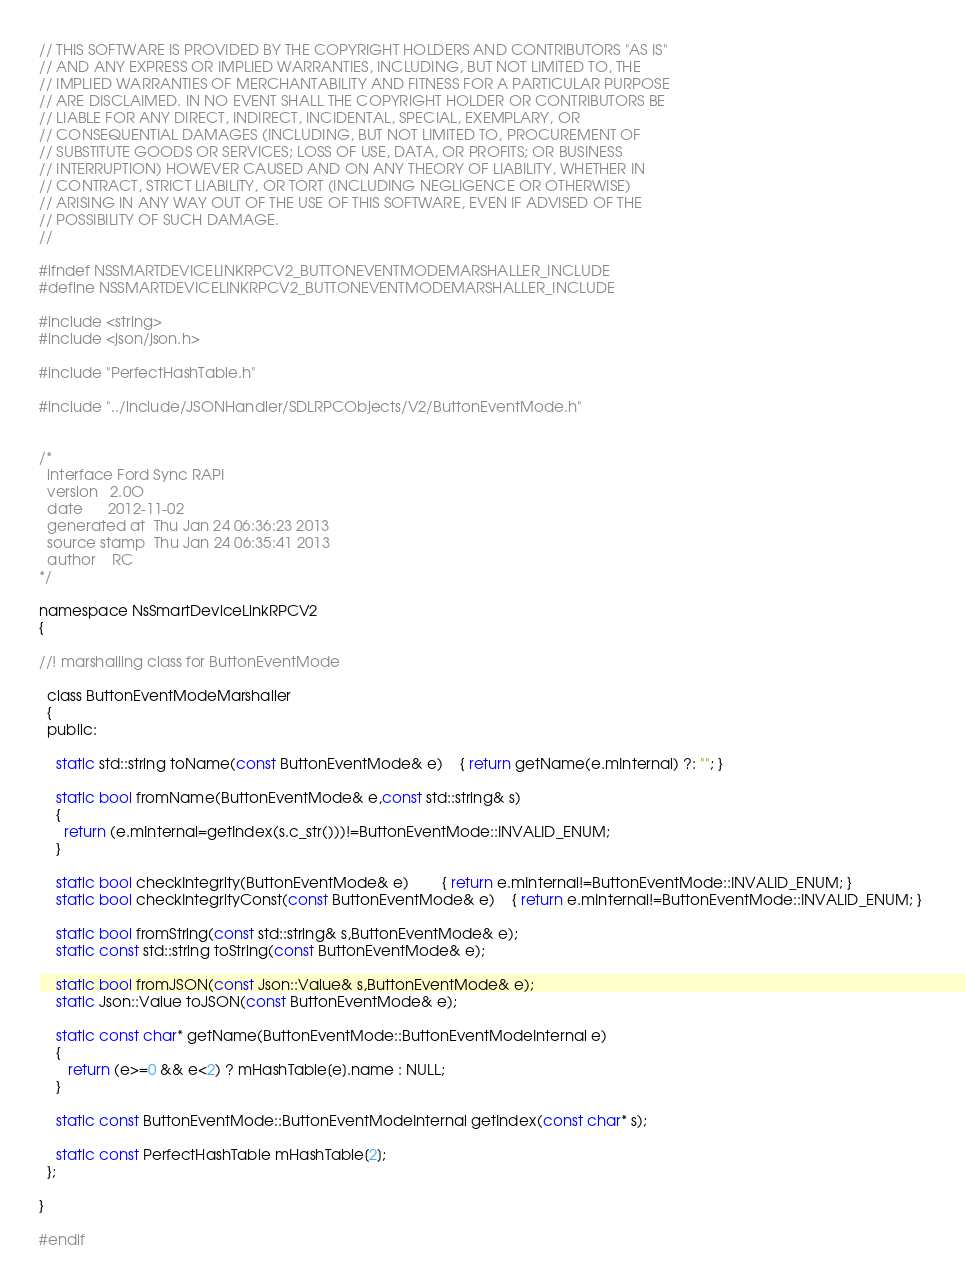<code> <loc_0><loc_0><loc_500><loc_500><_C_>// THIS SOFTWARE IS PROVIDED BY THE COPYRIGHT HOLDERS AND CONTRIBUTORS "AS IS"
// AND ANY EXPRESS OR IMPLIED WARRANTIES, INCLUDING, BUT NOT LIMITED TO, THE
// IMPLIED WARRANTIES OF MERCHANTABILITY AND FITNESS FOR A PARTICULAR PURPOSE
// ARE DISCLAIMED. IN NO EVENT SHALL THE COPYRIGHT HOLDER OR CONTRIBUTORS BE
// LIABLE FOR ANY DIRECT, INDIRECT, INCIDENTAL, SPECIAL, EXEMPLARY, OR
// CONSEQUENTIAL DAMAGES (INCLUDING, BUT NOT LIMITED TO, PROCUREMENT OF
// SUBSTITUTE GOODS OR SERVICES; LOSS OF USE, DATA, OR PROFITS; OR BUSINESS
// INTERRUPTION) HOWEVER CAUSED AND ON ANY THEORY OF LIABILITY, WHETHER IN
// CONTRACT, STRICT LIABILITY, OR TORT (INCLUDING NEGLIGENCE OR OTHERWISE)
// ARISING IN ANY WAY OUT OF THE USE OF THIS SOFTWARE, EVEN IF ADVISED OF THE
// POSSIBILITY OF SUCH DAMAGE.
//

#ifndef NSSMARTDEVICELINKRPCV2_BUTTONEVENTMODEMARSHALLER_INCLUDE
#define NSSMARTDEVICELINKRPCV2_BUTTONEVENTMODEMARSHALLER_INCLUDE

#include <string>
#include <json/json.h>

#include "PerfectHashTable.h"

#include "../include/JSONHandler/SDLRPCObjects/V2/ButtonEventMode.h"


/*
  interface	Ford Sync RAPI
  version	2.0O
  date		2012-11-02
  generated at	Thu Jan 24 06:36:23 2013
  source stamp	Thu Jan 24 06:35:41 2013
  author	RC
*/

namespace NsSmartDeviceLinkRPCV2
{

//! marshalling class for ButtonEventMode

  class ButtonEventModeMarshaller
  {
  public:
  
    static std::string toName(const ButtonEventMode& e) 	{ return getName(e.mInternal) ?: ""; }
  
    static bool fromName(ButtonEventMode& e,const std::string& s)
    { 
      return (e.mInternal=getIndex(s.c_str()))!=ButtonEventMode::INVALID_ENUM;
    }
  
    static bool checkIntegrity(ButtonEventMode& e)		{ return e.mInternal!=ButtonEventMode::INVALID_ENUM; } 
    static bool checkIntegrityConst(const ButtonEventMode& e)	{ return e.mInternal!=ButtonEventMode::INVALID_ENUM; } 
  
    static bool fromString(const std::string& s,ButtonEventMode& e);
    static const std::string toString(const ButtonEventMode& e);
  
    static bool fromJSON(const Json::Value& s,ButtonEventMode& e);
    static Json::Value toJSON(const ButtonEventMode& e);
  
    static const char* getName(ButtonEventMode::ButtonEventModeInternal e)
    {
       return (e>=0 && e<2) ? mHashTable[e].name : NULL;
    }
  
    static const ButtonEventMode::ButtonEventModeInternal getIndex(const char* s);
  
    static const PerfectHashTable mHashTable[2];
  };
  
}

#endif
</code> 